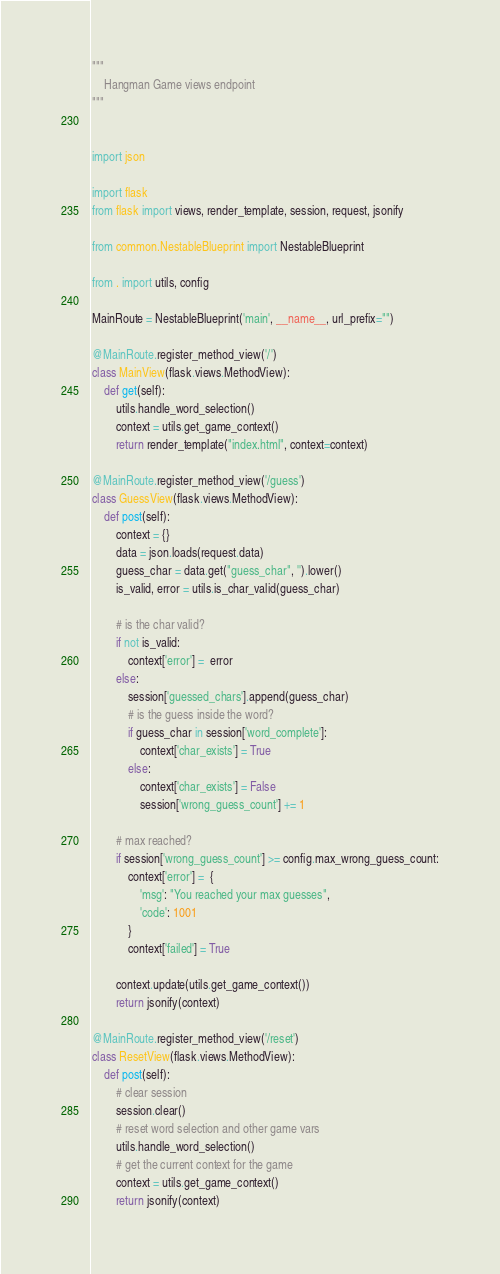Convert code to text. <code><loc_0><loc_0><loc_500><loc_500><_Python_>"""
    Hangman Game views endpoint
"""


import json

import flask
from flask import views, render_template, session, request, jsonify

from common.NestableBlueprint import NestableBlueprint

from . import utils, config

MainRoute = NestableBlueprint('main', __name__, url_prefix="")

@MainRoute.register_method_view('/')
class MainView(flask.views.MethodView):
    def get(self):
        utils.handle_word_selection()
        context = utils.get_game_context()
        return render_template("index.html", context=context)

@MainRoute.register_method_view('/guess')
class GuessView(flask.views.MethodView):
    def post(self):
        context = {}
        data = json.loads(request.data)
        guess_char = data.get("guess_char", '').lower()
        is_valid, error = utils.is_char_valid(guess_char)

        # is the char valid?
        if not is_valid:
            context['error'] =  error
        else:
            session['guessed_chars'].append(guess_char)
            # is the guess inside the word?
            if guess_char in session['word_complete']:
                context['char_exists'] = True
            else:
                context['char_exists'] = False
                session['wrong_guess_count'] += 1

        # max reached?
        if session['wrong_guess_count'] >= config.max_wrong_guess_count:
            context['error'] =  {
                'msg': "You reached your max guesses",
                'code': 1001
            }
            context['failed'] = True

        context.update(utils.get_game_context())
        return jsonify(context)

@MainRoute.register_method_view('/reset')
class ResetView(flask.views.MethodView):
    def post(self):
        # clear session
        session.clear()
        # reset word selection and other game vars
        utils.handle_word_selection()
        # get the current context for the game
        context = utils.get_game_context()
        return jsonify(context)
</code> 